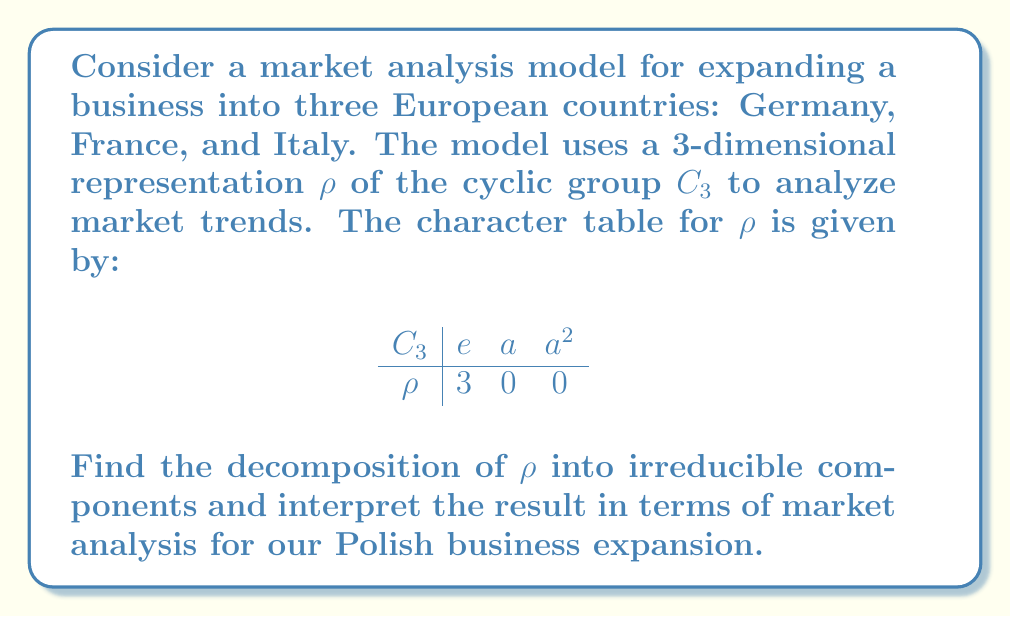Teach me how to tackle this problem. To decompose the representation $\rho$ into irreducible components, we'll follow these steps:

1) First, recall the character table for $C_3$:

$$
\begin{array}{c|ccc}
C_3 & e & a & a^2 \\
\hline
\chi_1 & 1 & 1 & 1 \\
\chi_2 & 1 & \omega & \omega^2 \\
\chi_3 & 1 & \omega^2 & \omega
\end{array}
$$

where $\omega = e^{2\pi i/3}$ is a primitive third root of unity.

2) To find the multiplicity of each irreducible representation in $\rho$, we use the formula:

$$ m_i = \frac{1}{|G|} \sum_{g \in G} \chi_\rho(g) \overline{\chi_i(g)} $$

3) For $\chi_1$:
$$ m_1 = \frac{1}{3}(3 \cdot 1 + 0 \cdot 1 + 0 \cdot 1) = 1 $$

4) For $\chi_2$:
$$ m_2 = \frac{1}{3}(3 \cdot 1 + 0 \cdot \omega^2 + 0 \cdot \omega) = 1 $$

5) For $\chi_3$:
$$ m_3 = \frac{1}{3}(3 \cdot 1 + 0 \cdot \omega + 0 \cdot \omega^2) = 1 $$

6) Therefore, the decomposition of $\rho$ is:

$$ \rho = \chi_1 \oplus \chi_2 \oplus \chi_3 $$

Interpretation: This decomposition suggests that our market analysis model for the Polish business expansion into Germany, France, and Italy can be broken down into three independent components:

- $\chi_1$ represents the overall market trend common to all three countries.
- $\chi_2$ and $\chi_3$ represent cyclic patterns in market behavior that differ between the countries, possibly reflecting seasonal trends or economic cycles specific to each market.
Answer: $\rho = \chi_1 \oplus \chi_2 \oplus \chi_3$ 